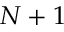<formula> <loc_0><loc_0><loc_500><loc_500>N + 1</formula> 